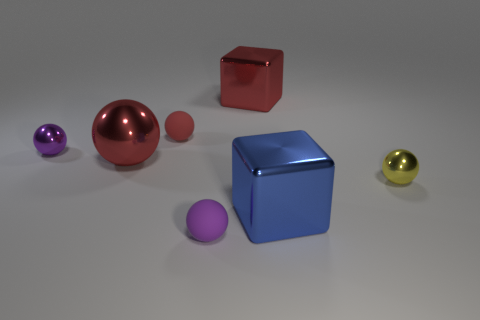Subtract all large red shiny spheres. How many spheres are left? 4 Add 2 small shiny spheres. How many objects exist? 9 Subtract all blue blocks. How many blocks are left? 1 Subtract all spheres. How many objects are left? 2 Subtract 2 spheres. How many spheres are left? 3 Add 4 small green metallic cylinders. How many small green metallic cylinders exist? 4 Subtract 1 yellow balls. How many objects are left? 6 Subtract all brown cubes. Subtract all green spheres. How many cubes are left? 2 Subtract all brown balls. How many red cubes are left? 1 Subtract all gray cylinders. Subtract all yellow objects. How many objects are left? 6 